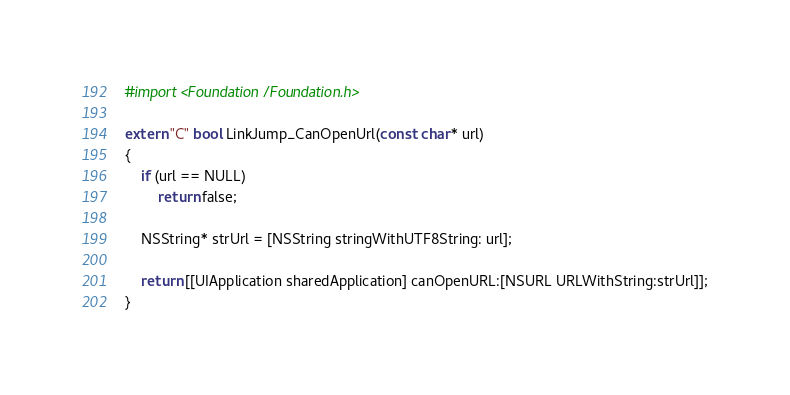Convert code to text. <code><loc_0><loc_0><loc_500><loc_500><_ObjectiveC_>#import <Foundation/Foundation.h>

extern "C" bool LinkJump_CanOpenUrl(const char* url)
{
    if (url == NULL)
        return false;
    
    NSString* strUrl = [NSString stringWithUTF8String: url];
    
    return [[UIApplication sharedApplication] canOpenURL:[NSURL URLWithString:strUrl]];
}
</code> 